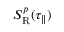Convert formula to latex. <formula><loc_0><loc_0><loc_500><loc_500>S _ { R } ^ { p } ( \tau _ { \| } )</formula> 